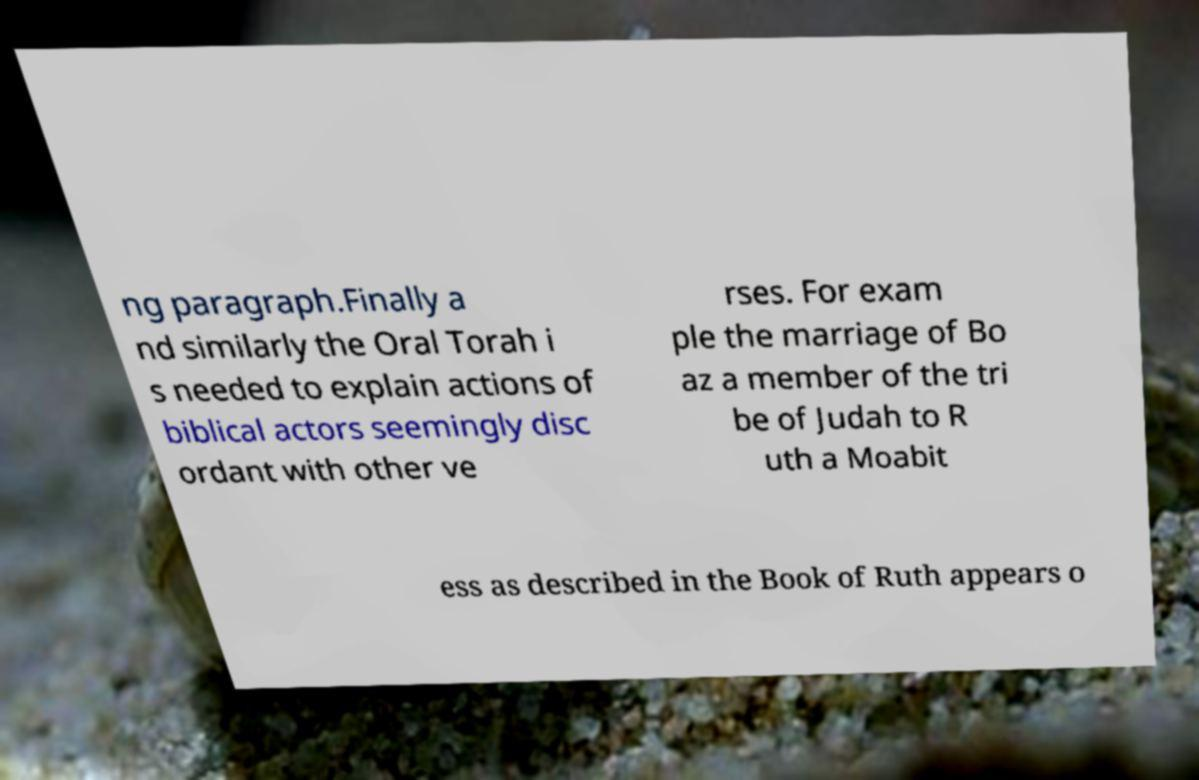Please identify and transcribe the text found in this image. ng paragraph.Finally a nd similarly the Oral Torah i s needed to explain actions of biblical actors seemingly disc ordant with other ve rses. For exam ple the marriage of Bo az a member of the tri be of Judah to R uth a Moabit ess as described in the Book of Ruth appears o 